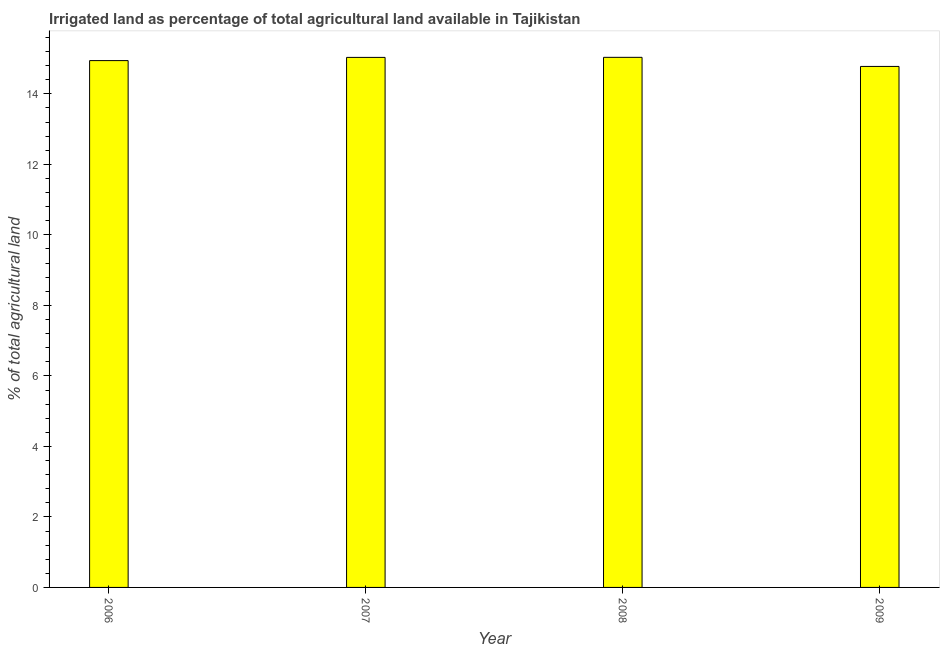Does the graph contain grids?
Ensure brevity in your answer.  No. What is the title of the graph?
Your response must be concise. Irrigated land as percentage of total agricultural land available in Tajikistan. What is the label or title of the X-axis?
Offer a terse response. Year. What is the label or title of the Y-axis?
Ensure brevity in your answer.  % of total agricultural land. What is the percentage of agricultural irrigated land in 2006?
Provide a short and direct response. 14.94. Across all years, what is the maximum percentage of agricultural irrigated land?
Ensure brevity in your answer.  15.04. Across all years, what is the minimum percentage of agricultural irrigated land?
Offer a very short reply. 14.78. What is the sum of the percentage of agricultural irrigated land?
Provide a succinct answer. 59.79. What is the difference between the percentage of agricultural irrigated land in 2006 and 2007?
Keep it short and to the point. -0.09. What is the average percentage of agricultural irrigated land per year?
Offer a terse response. 14.95. What is the median percentage of agricultural irrigated land?
Your response must be concise. 14.99. What is the ratio of the percentage of agricultural irrigated land in 2006 to that in 2009?
Ensure brevity in your answer.  1.01. What is the difference between the highest and the second highest percentage of agricultural irrigated land?
Give a very brief answer. 0. What is the difference between the highest and the lowest percentage of agricultural irrigated land?
Make the answer very short. 0.26. In how many years, is the percentage of agricultural irrigated land greater than the average percentage of agricultural irrigated land taken over all years?
Provide a short and direct response. 2. How many bars are there?
Your answer should be very brief. 4. How many years are there in the graph?
Ensure brevity in your answer.  4. What is the difference between two consecutive major ticks on the Y-axis?
Offer a terse response. 2. Are the values on the major ticks of Y-axis written in scientific E-notation?
Your answer should be compact. No. What is the % of total agricultural land of 2006?
Your response must be concise. 14.94. What is the % of total agricultural land in 2007?
Provide a short and direct response. 15.03. What is the % of total agricultural land of 2008?
Offer a very short reply. 15.04. What is the % of total agricultural land of 2009?
Give a very brief answer. 14.78. What is the difference between the % of total agricultural land in 2006 and 2007?
Give a very brief answer. -0.09. What is the difference between the % of total agricultural land in 2006 and 2008?
Provide a succinct answer. -0.09. What is the difference between the % of total agricultural land in 2006 and 2009?
Ensure brevity in your answer.  0.17. What is the difference between the % of total agricultural land in 2007 and 2008?
Your answer should be compact. -0. What is the difference between the % of total agricultural land in 2007 and 2009?
Keep it short and to the point. 0.26. What is the difference between the % of total agricultural land in 2008 and 2009?
Provide a succinct answer. 0.26. What is the ratio of the % of total agricultural land in 2006 to that in 2008?
Ensure brevity in your answer.  0.99. What is the ratio of the % of total agricultural land in 2007 to that in 2008?
Give a very brief answer. 1. 